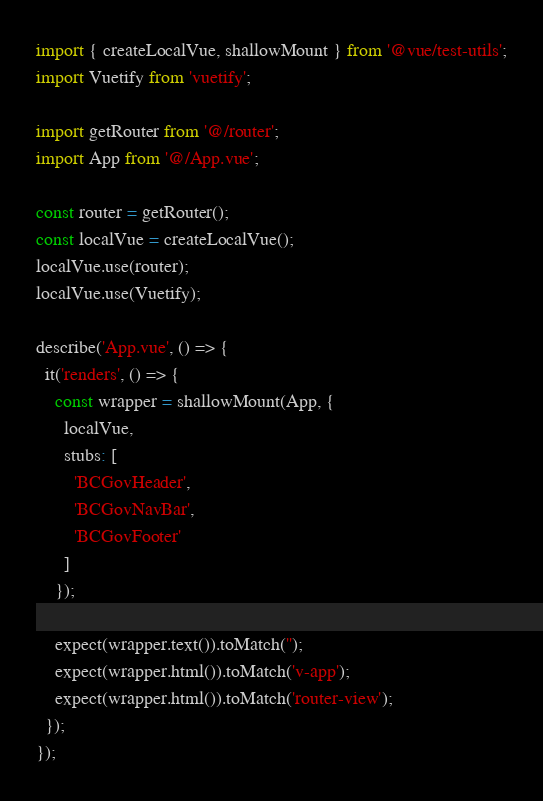Convert code to text. <code><loc_0><loc_0><loc_500><loc_500><_JavaScript_>import { createLocalVue, shallowMount } from '@vue/test-utils';
import Vuetify from 'vuetify';

import getRouter from '@/router';
import App from '@/App.vue';

const router = getRouter();
const localVue = createLocalVue();
localVue.use(router);
localVue.use(Vuetify);

describe('App.vue', () => {
  it('renders', () => {
    const wrapper = shallowMount(App, {
      localVue,
      stubs: [
        'BCGovHeader',
        'BCGovNavBar',
        'BCGovFooter'
      ]
    });

    expect(wrapper.text()).toMatch('');
    expect(wrapper.html()).toMatch('v-app');
    expect(wrapper.html()).toMatch('router-view');
  });
});
</code> 